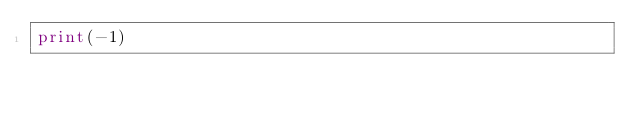<code> <loc_0><loc_0><loc_500><loc_500><_Python_>print(-1)</code> 